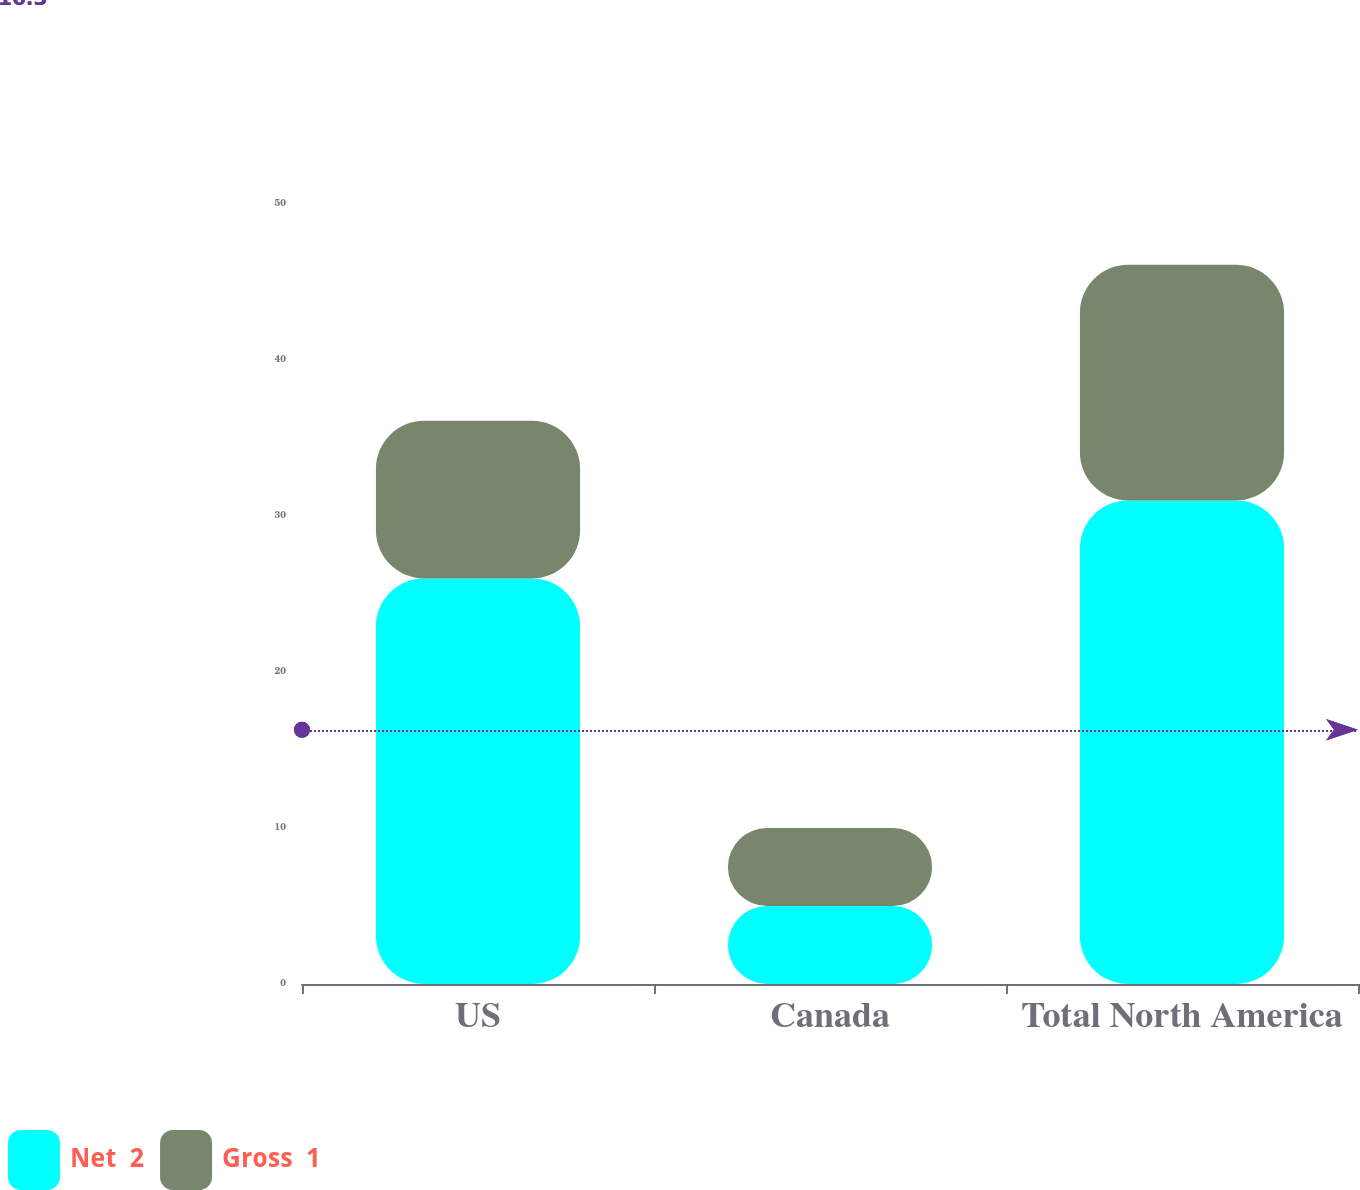<chart> <loc_0><loc_0><loc_500><loc_500><stacked_bar_chart><ecel><fcel>US<fcel>Canada<fcel>Total North America<nl><fcel>Net  2<fcel>26<fcel>5<fcel>31<nl><fcel>Gross  1<fcel>10.1<fcel>5<fcel>15.1<nl></chart> 